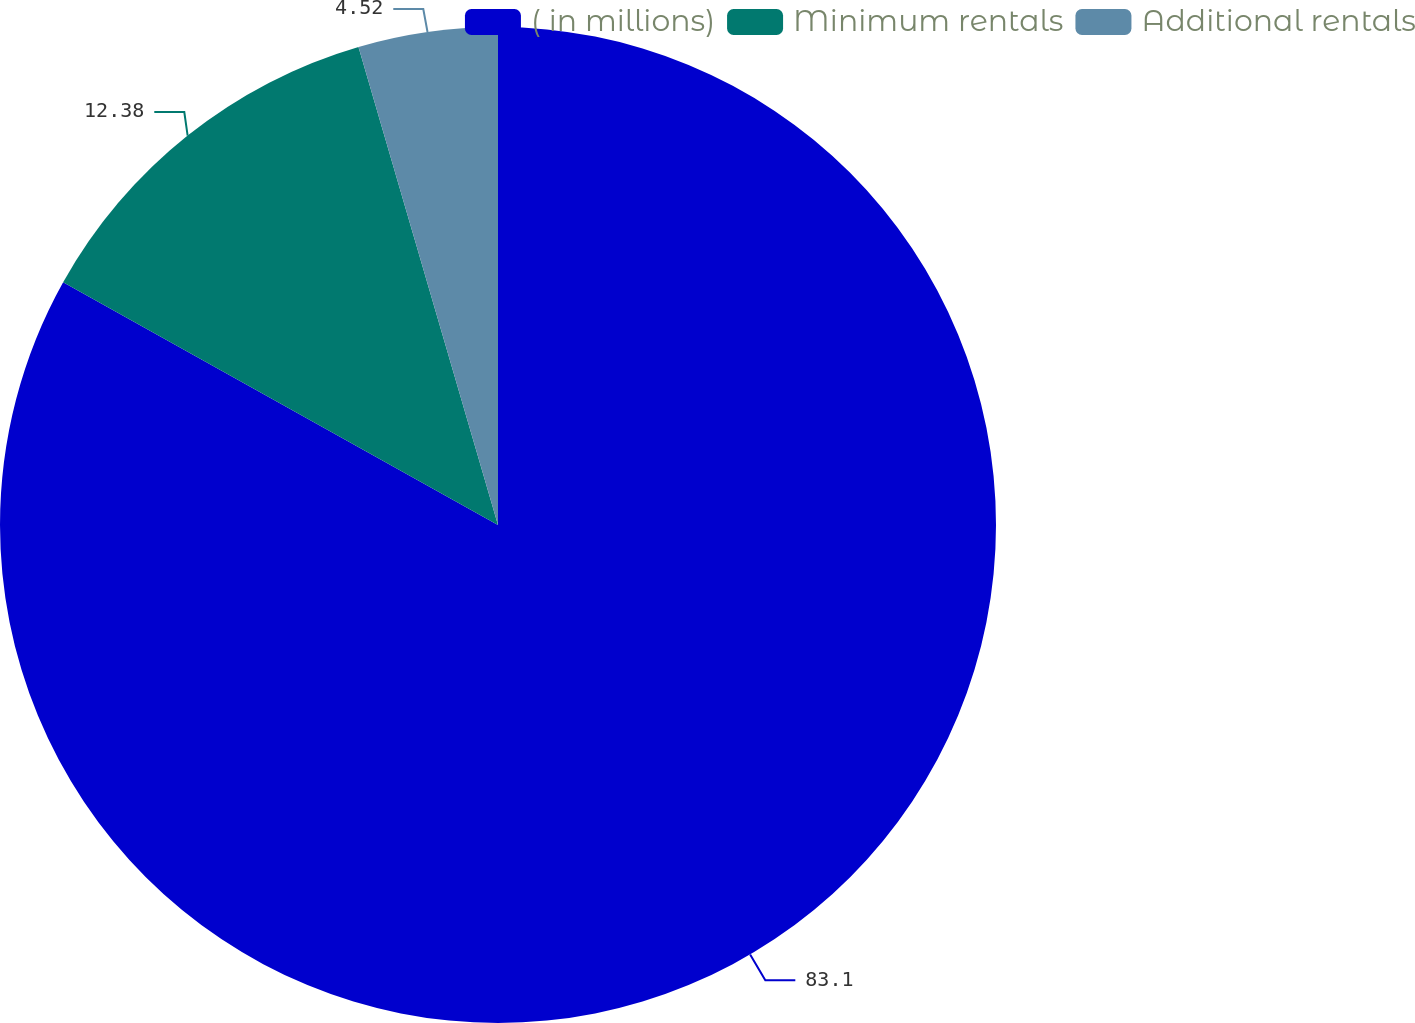Convert chart to OTSL. <chart><loc_0><loc_0><loc_500><loc_500><pie_chart><fcel>( in millions)<fcel>Minimum rentals<fcel>Additional rentals<nl><fcel>83.11%<fcel>12.38%<fcel>4.52%<nl></chart> 